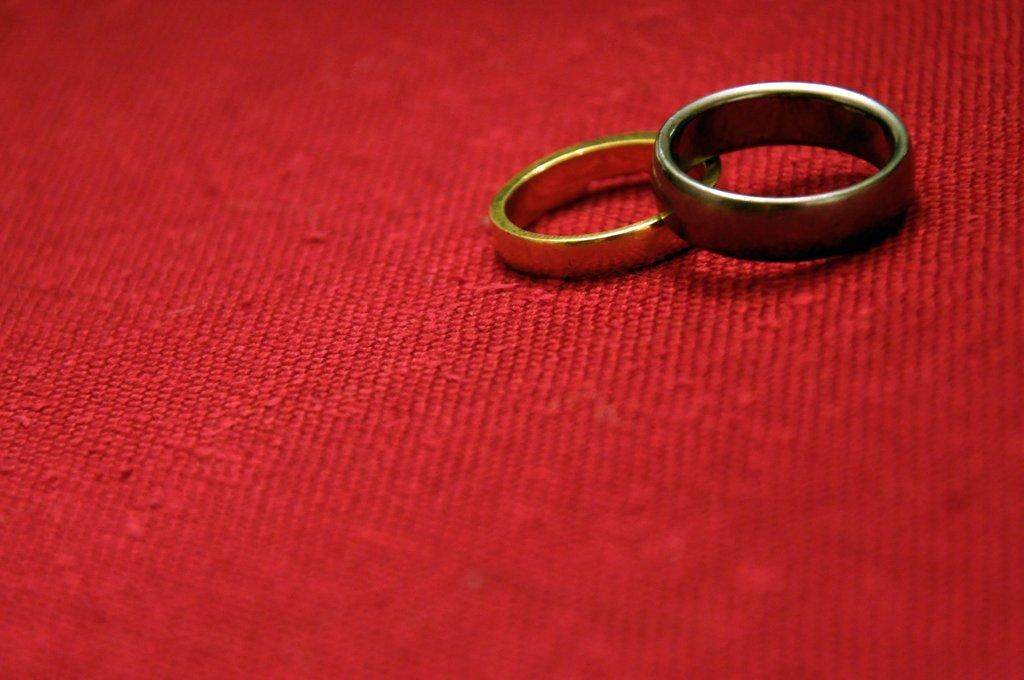What objects are present in the image? There are rings in the image. What color is the surface on which the rings are placed? The rings are on a red surface. What type of riddle can be solved using the rings in the image? There is no riddle present in the image, and the rings cannot be used to solve a riddle. 